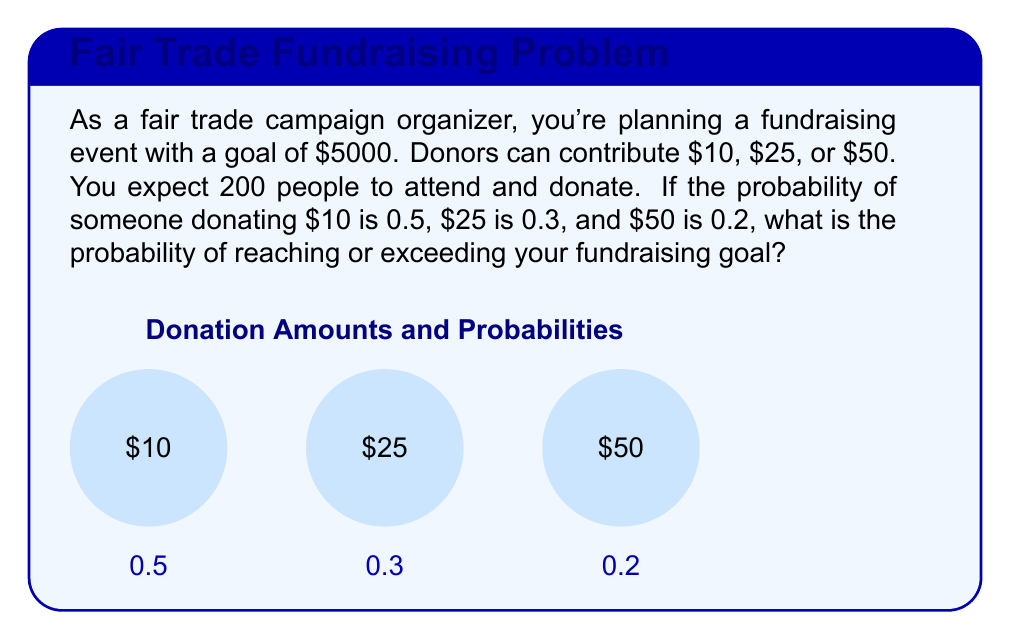Solve this math problem. Let's approach this step-by-step:

1) First, we need to calculate the expected value of a single donation:
   $E = 10 \cdot 0.5 + 25 \cdot 0.3 + 50 \cdot 0.2 = 5 + 7.5 + 10 = 22.5$

2) For 200 people, the expected total donation is:
   $200 \cdot 22.5 = 4500$

3) The standard deviation for a single donation is:
   $\sigma = \sqrt{(10-22.5)^2 \cdot 0.5 + (25-22.5)^2 \cdot 0.3 + (50-22.5)^2 \cdot 0.2}$
   $= \sqrt{78.125 + 1.875 + 150.625} = \sqrt{230.625} \approx 15.19$

4) For 200 independent donations, the standard deviation is:
   $\sigma_{200} = 15.19 \cdot \sqrt{200} \approx 214.85$

5) We can use the Central Limit Theorem to approximate the distribution of total donations as normal. We want to find the probability of reaching at least $5000:

   $Z = \frac{5000 - 4500}{214.85} \approx 2.33$

6) Using a standard normal table or calculator, we find:
   $P(Z > 2.33) \approx 0.0099$

Therefore, the probability of reaching or exceeding the $5000 goal is approximately 0.0099 or 0.99%.
Answer: $0.0099$ or $0.99\%$ 